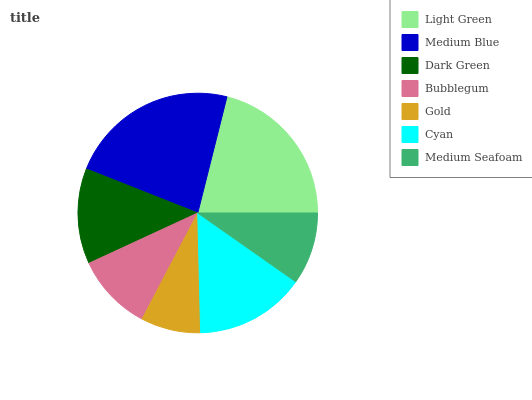Is Gold the minimum?
Answer yes or no. Yes. Is Medium Blue the maximum?
Answer yes or no. Yes. Is Dark Green the minimum?
Answer yes or no. No. Is Dark Green the maximum?
Answer yes or no. No. Is Medium Blue greater than Dark Green?
Answer yes or no. Yes. Is Dark Green less than Medium Blue?
Answer yes or no. Yes. Is Dark Green greater than Medium Blue?
Answer yes or no. No. Is Medium Blue less than Dark Green?
Answer yes or no. No. Is Dark Green the high median?
Answer yes or no. Yes. Is Dark Green the low median?
Answer yes or no. Yes. Is Medium Blue the high median?
Answer yes or no. No. Is Light Green the low median?
Answer yes or no. No. 